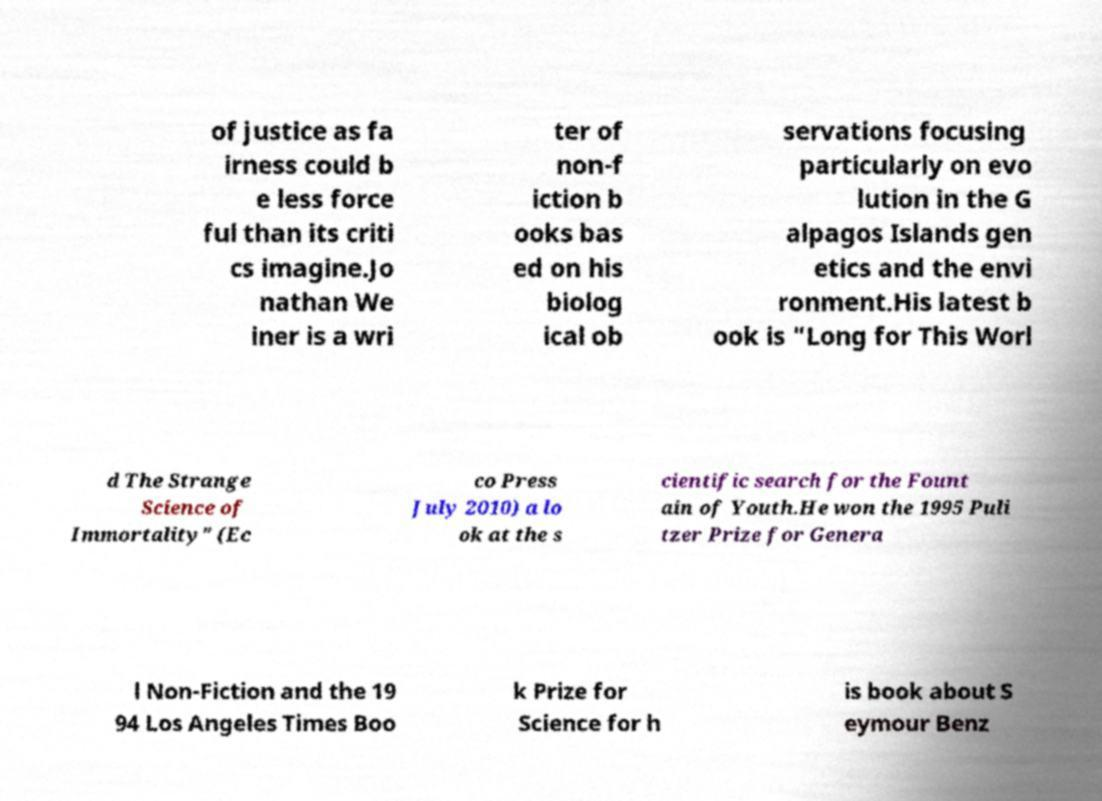Please identify and transcribe the text found in this image. of justice as fa irness could b e less force ful than its criti cs imagine.Jo nathan We iner is a wri ter of non-f iction b ooks bas ed on his biolog ical ob servations focusing particularly on evo lution in the G alpagos Islands gen etics and the envi ronment.His latest b ook is "Long for This Worl d The Strange Science of Immortality" (Ec co Press July 2010) a lo ok at the s cientific search for the Fount ain of Youth.He won the 1995 Puli tzer Prize for Genera l Non-Fiction and the 19 94 Los Angeles Times Boo k Prize for Science for h is book about S eymour Benz 